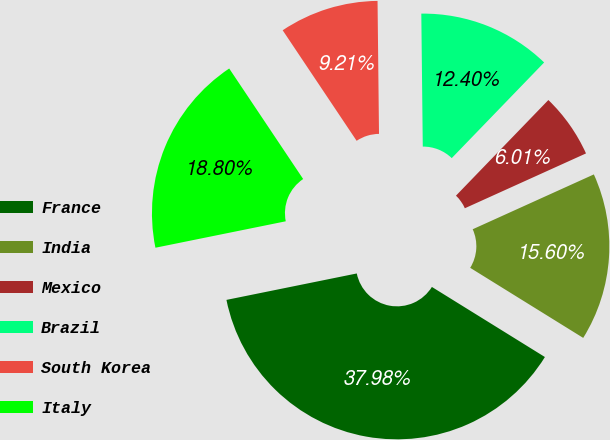Convert chart. <chart><loc_0><loc_0><loc_500><loc_500><pie_chart><fcel>France<fcel>India<fcel>Mexico<fcel>Brazil<fcel>South Korea<fcel>Italy<nl><fcel>37.98%<fcel>15.6%<fcel>6.01%<fcel>12.4%<fcel>9.21%<fcel>18.8%<nl></chart> 